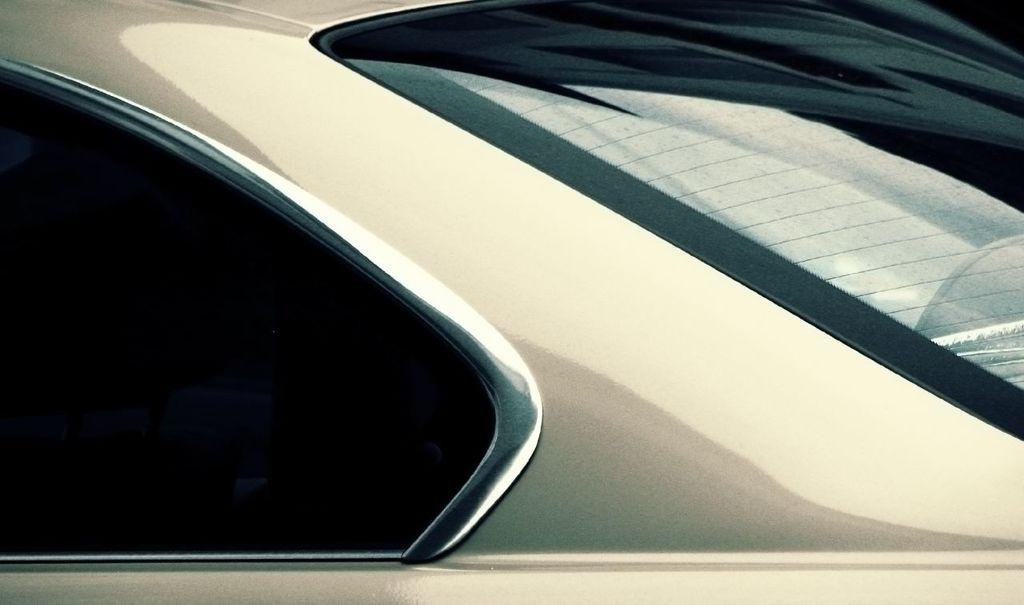What is the main subject of the image? There is a vehicle in the image. Can you describe the location of the glass in relation to the vehicle? There is a glass on the right side of the vehicle. What type of shoe is the teacher wearing in the image? There is no teacher or shoe present in the image; it only features a vehicle and a glass. 